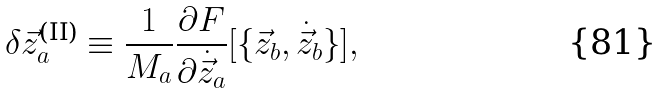<formula> <loc_0><loc_0><loc_500><loc_500>\delta \vec { z } _ { a } ^ { \text {(II)} } & \equiv \frac { 1 } { M _ { a } } \frac { \partial F } { \partial \dot { \vec { z } } _ { a } } [ \{ \vec { z } _ { b } , \dot { \vec { z } } _ { b } \} ] ,</formula> 